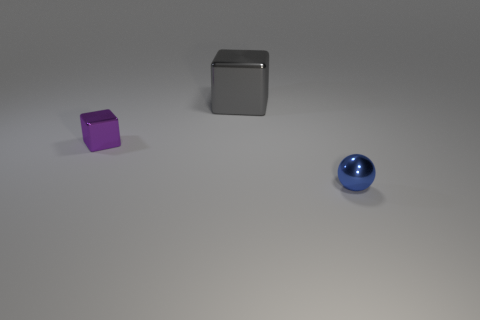How many other things are the same size as the gray shiny object?
Your response must be concise. 0. There is a thing that is right of the block behind the tiny purple metallic block; what size is it?
Keep it short and to the point. Small. What is the color of the tiny thing in front of the small thing that is behind the sphere that is in front of the purple metal thing?
Keep it short and to the point. Blue. What is the size of the metallic thing that is both right of the small purple metal block and to the left of the tiny blue thing?
Make the answer very short. Large. What number of other things are there of the same shape as the tiny blue thing?
Provide a short and direct response. 0. What number of blocks are either gray metallic things or large purple things?
Keep it short and to the point. 1. There is a cube to the right of the tiny metal object that is left of the tiny blue sphere; are there any metallic blocks on the left side of it?
Make the answer very short. Yes. What color is the other metal thing that is the same shape as the purple thing?
Your answer should be very brief. Gray. How many blue objects are large cubes or small spheres?
Offer a terse response. 1. What is the material of the object that is on the left side of the thing that is behind the purple metal cube?
Give a very brief answer. Metal. 